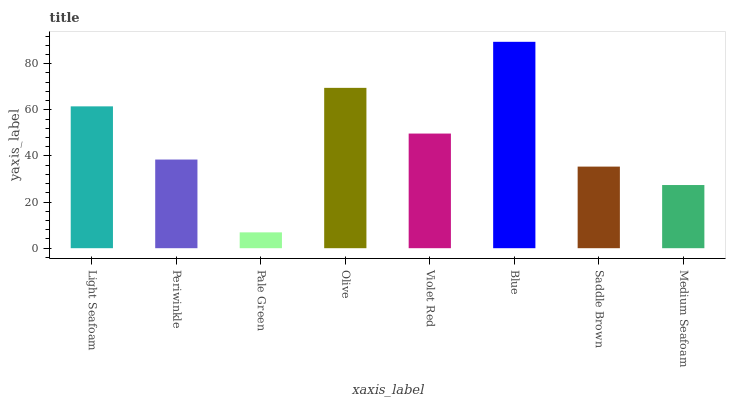Is Pale Green the minimum?
Answer yes or no. Yes. Is Blue the maximum?
Answer yes or no. Yes. Is Periwinkle the minimum?
Answer yes or no. No. Is Periwinkle the maximum?
Answer yes or no. No. Is Light Seafoam greater than Periwinkle?
Answer yes or no. Yes. Is Periwinkle less than Light Seafoam?
Answer yes or no. Yes. Is Periwinkle greater than Light Seafoam?
Answer yes or no. No. Is Light Seafoam less than Periwinkle?
Answer yes or no. No. Is Violet Red the high median?
Answer yes or no. Yes. Is Periwinkle the low median?
Answer yes or no. Yes. Is Olive the high median?
Answer yes or no. No. Is Light Seafoam the low median?
Answer yes or no. No. 